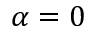Convert formula to latex. <formula><loc_0><loc_0><loc_500><loc_500>\alpha = 0</formula> 